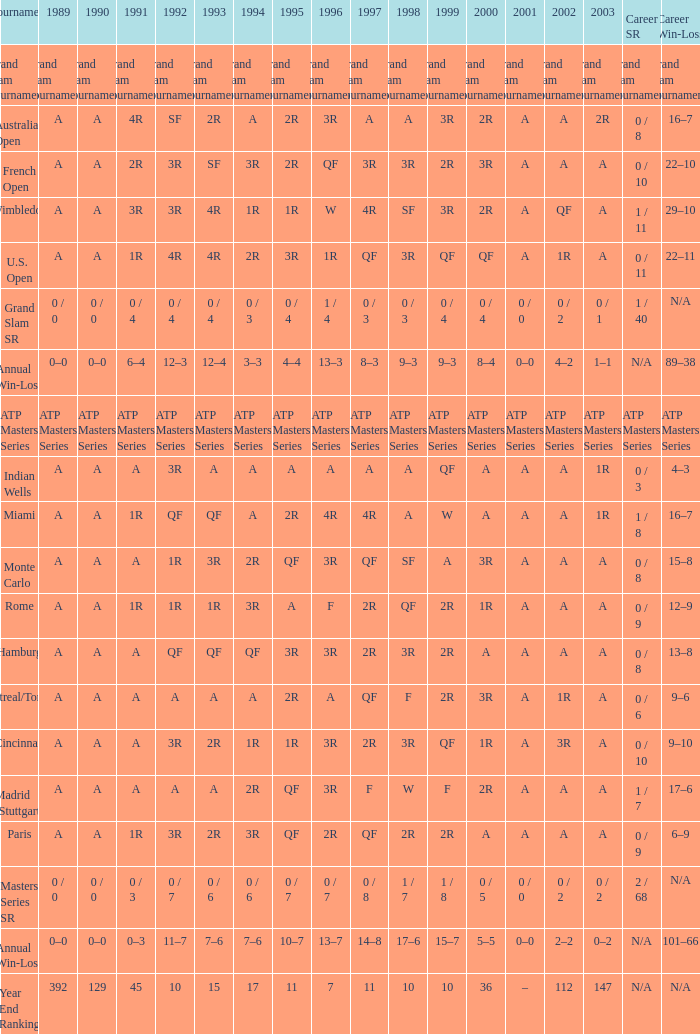What was the valuation in 1989 with qf in 1997 and a in 1993? A. 